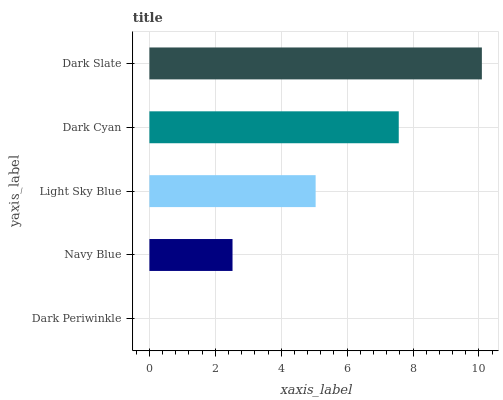Is Dark Periwinkle the minimum?
Answer yes or no. Yes. Is Dark Slate the maximum?
Answer yes or no. Yes. Is Navy Blue the minimum?
Answer yes or no. No. Is Navy Blue the maximum?
Answer yes or no. No. Is Navy Blue greater than Dark Periwinkle?
Answer yes or no. Yes. Is Dark Periwinkle less than Navy Blue?
Answer yes or no. Yes. Is Dark Periwinkle greater than Navy Blue?
Answer yes or no. No. Is Navy Blue less than Dark Periwinkle?
Answer yes or no. No. Is Light Sky Blue the high median?
Answer yes or no. Yes. Is Light Sky Blue the low median?
Answer yes or no. Yes. Is Dark Cyan the high median?
Answer yes or no. No. Is Dark Periwinkle the low median?
Answer yes or no. No. 